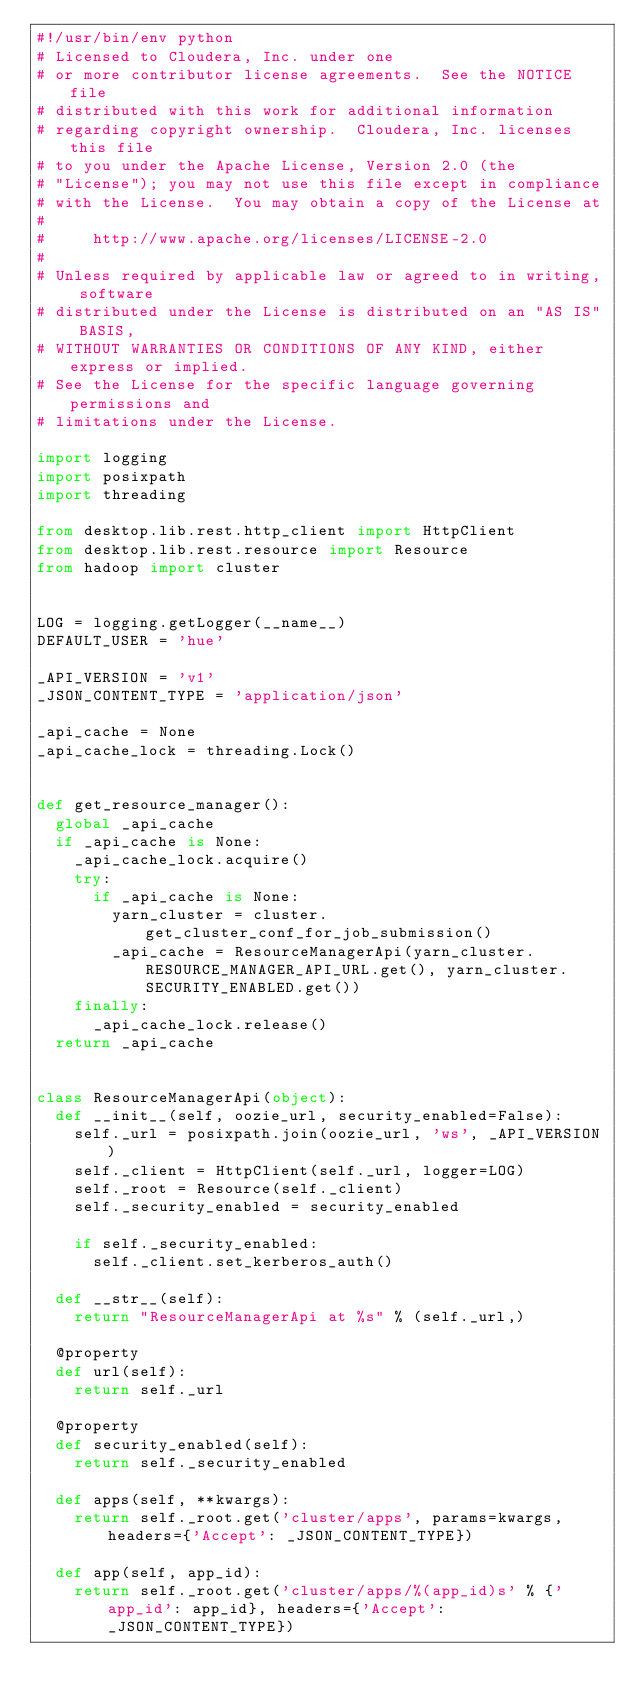Convert code to text. <code><loc_0><loc_0><loc_500><loc_500><_Python_>#!/usr/bin/env python
# Licensed to Cloudera, Inc. under one
# or more contributor license agreements.  See the NOTICE file
# distributed with this work for additional information
# regarding copyright ownership.  Cloudera, Inc. licenses this file
# to you under the Apache License, Version 2.0 (the
# "License"); you may not use this file except in compliance
# with the License.  You may obtain a copy of the License at
#
#     http://www.apache.org/licenses/LICENSE-2.0
#
# Unless required by applicable law or agreed to in writing, software
# distributed under the License is distributed on an "AS IS" BASIS,
# WITHOUT WARRANTIES OR CONDITIONS OF ANY KIND, either express or implied.
# See the License for the specific language governing permissions and
# limitations under the License.

import logging
import posixpath
import threading

from desktop.lib.rest.http_client import HttpClient
from desktop.lib.rest.resource import Resource
from hadoop import cluster


LOG = logging.getLogger(__name__)
DEFAULT_USER = 'hue'

_API_VERSION = 'v1'
_JSON_CONTENT_TYPE = 'application/json'

_api_cache = None
_api_cache_lock = threading.Lock()


def get_resource_manager():
  global _api_cache
  if _api_cache is None:
    _api_cache_lock.acquire()
    try:
      if _api_cache is None:
        yarn_cluster = cluster.get_cluster_conf_for_job_submission()
        _api_cache = ResourceManagerApi(yarn_cluster.RESOURCE_MANAGER_API_URL.get(), yarn_cluster.SECURITY_ENABLED.get())
    finally:
      _api_cache_lock.release()
  return _api_cache


class ResourceManagerApi(object):
  def __init__(self, oozie_url, security_enabled=False):
    self._url = posixpath.join(oozie_url, 'ws', _API_VERSION)
    self._client = HttpClient(self._url, logger=LOG)
    self._root = Resource(self._client)
    self._security_enabled = security_enabled

    if self._security_enabled:
      self._client.set_kerberos_auth()

  def __str__(self):
    return "ResourceManagerApi at %s" % (self._url,)

  @property
  def url(self):
    return self._url

  @property
  def security_enabled(self):
    return self._security_enabled

  def apps(self, **kwargs):
    return self._root.get('cluster/apps', params=kwargs, headers={'Accept': _JSON_CONTENT_TYPE})

  def app(self, app_id):
    return self._root.get('cluster/apps/%(app_id)s' % {'app_id': app_id}, headers={'Accept': _JSON_CONTENT_TYPE})
</code> 